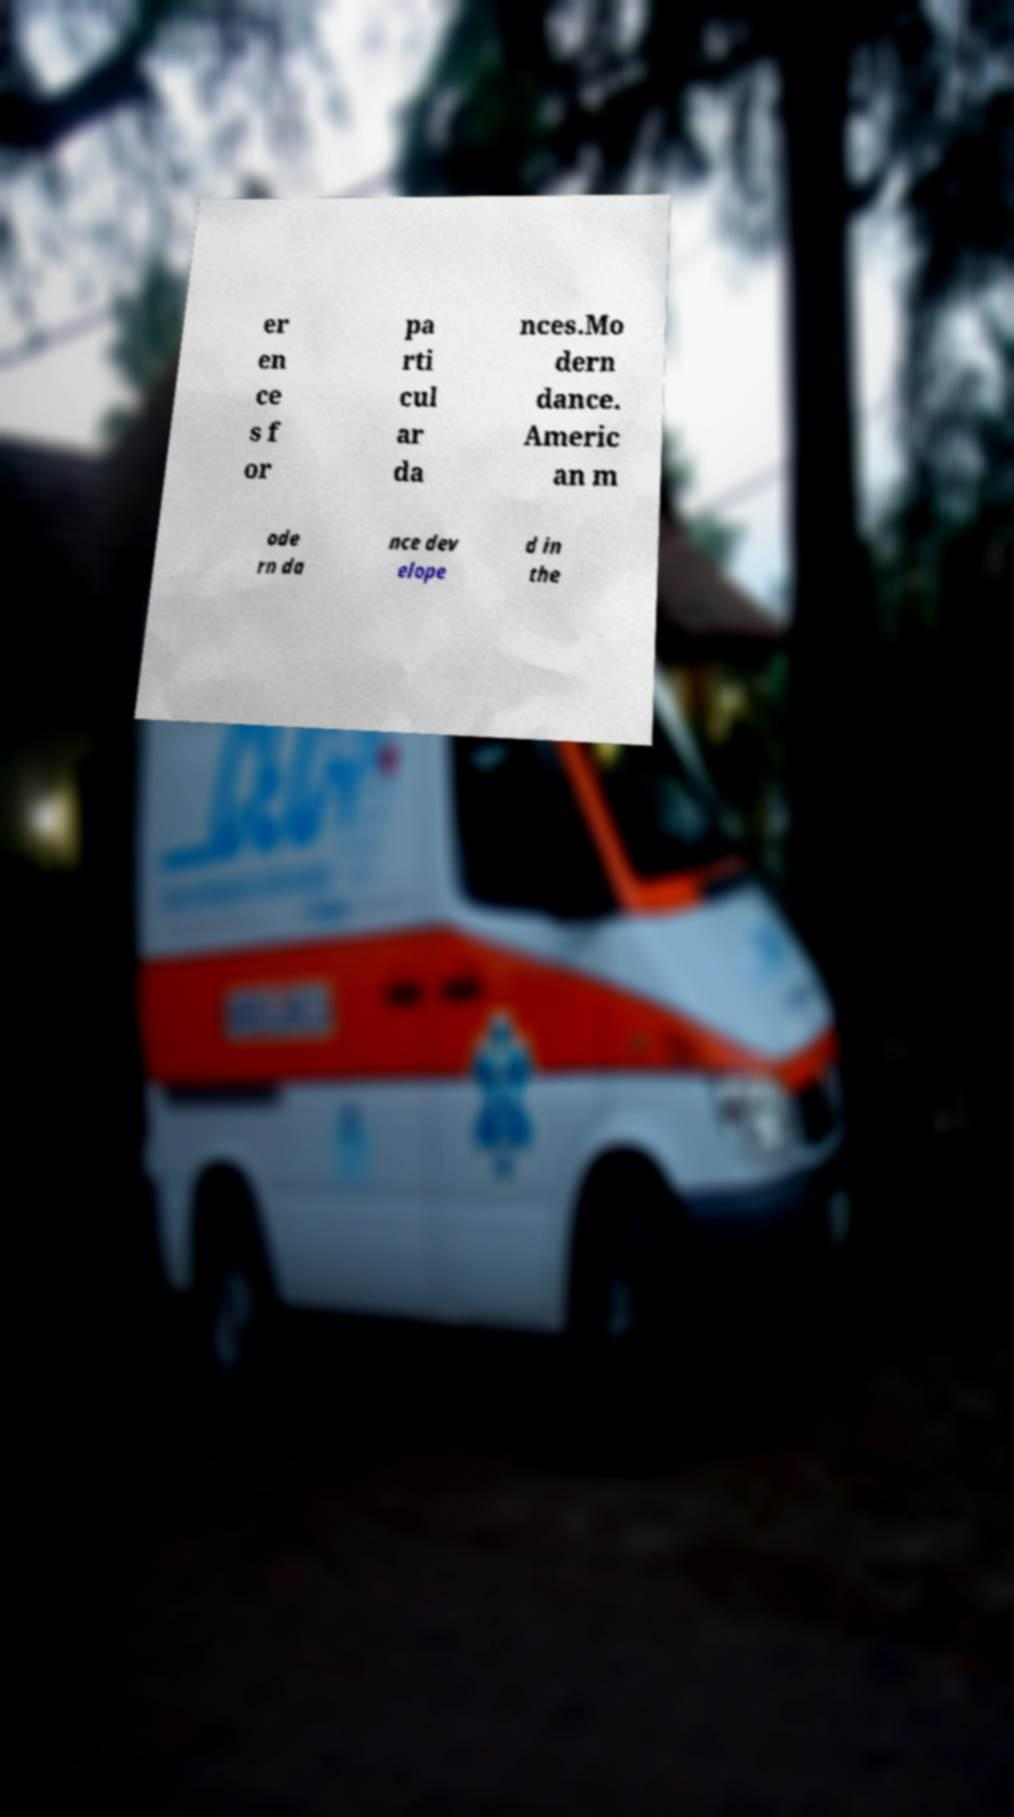Could you assist in decoding the text presented in this image and type it out clearly? er en ce s f or pa rti cul ar da nces.Mo dern dance. Americ an m ode rn da nce dev elope d in the 